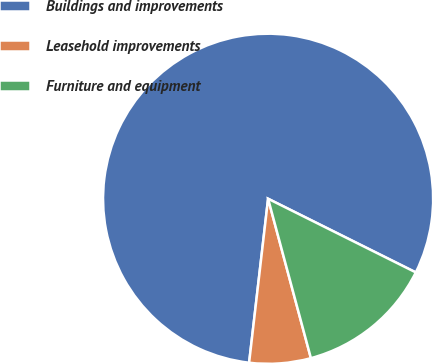Convert chart. <chart><loc_0><loc_0><loc_500><loc_500><pie_chart><fcel>Buildings and improvements<fcel>Leasehold improvements<fcel>Furniture and equipment<nl><fcel>80.52%<fcel>6.01%<fcel>13.46%<nl></chart> 